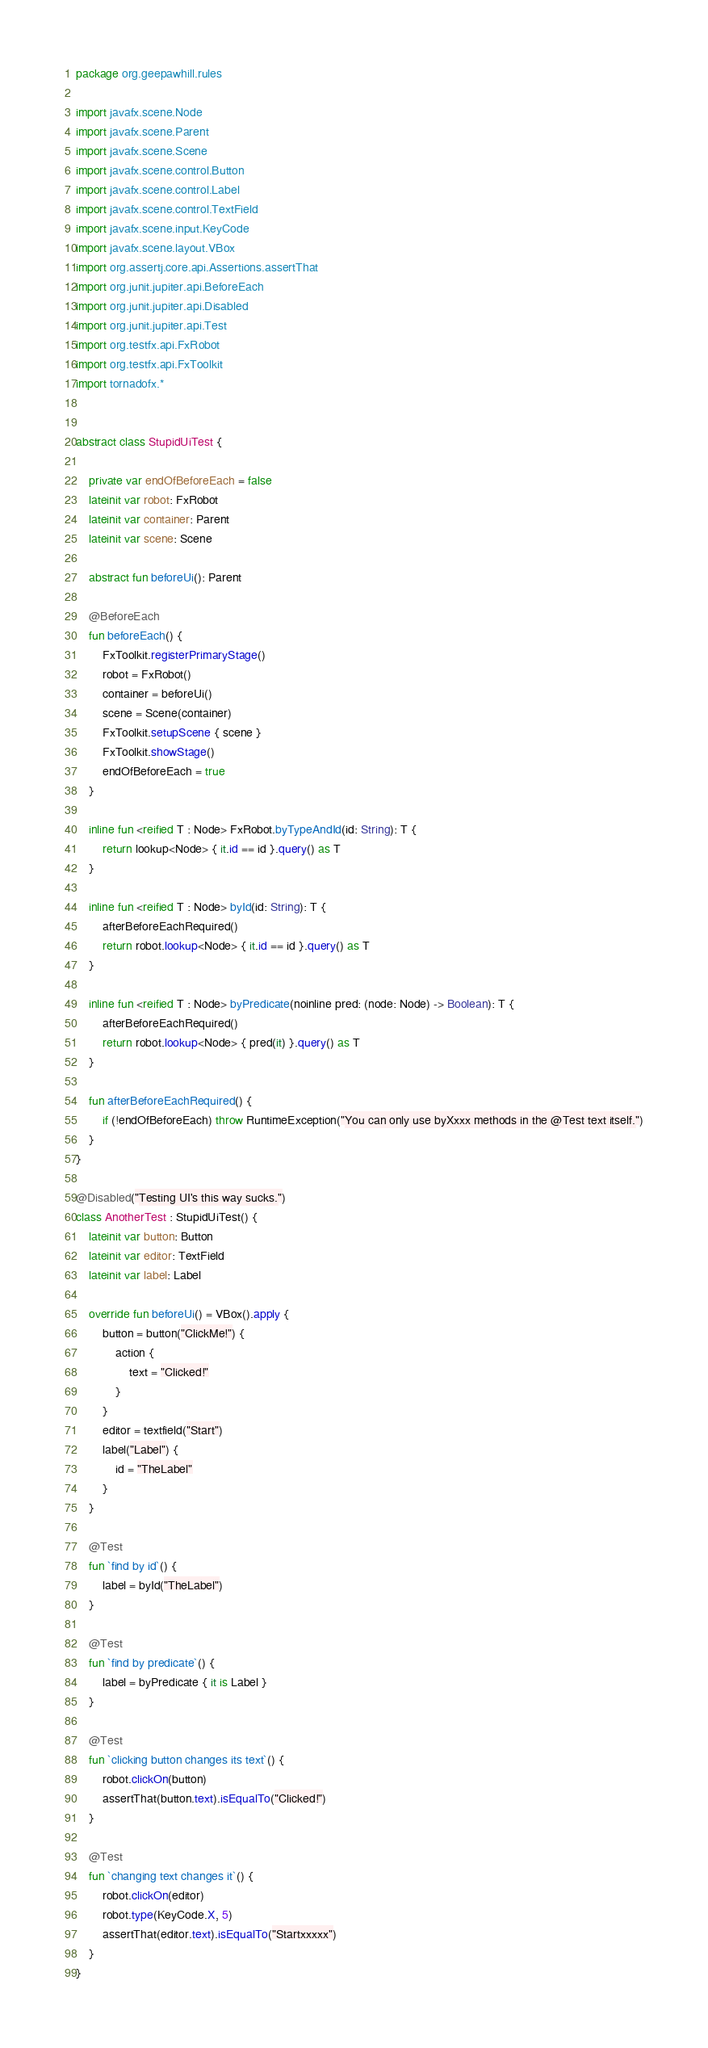Convert code to text. <code><loc_0><loc_0><loc_500><loc_500><_Kotlin_>package org.geepawhill.rules

import javafx.scene.Node
import javafx.scene.Parent
import javafx.scene.Scene
import javafx.scene.control.Button
import javafx.scene.control.Label
import javafx.scene.control.TextField
import javafx.scene.input.KeyCode
import javafx.scene.layout.VBox
import org.assertj.core.api.Assertions.assertThat
import org.junit.jupiter.api.BeforeEach
import org.junit.jupiter.api.Disabled
import org.junit.jupiter.api.Test
import org.testfx.api.FxRobot
import org.testfx.api.FxToolkit
import tornadofx.*


abstract class StupidUiTest {

    private var endOfBeforeEach = false
    lateinit var robot: FxRobot
    lateinit var container: Parent
    lateinit var scene: Scene

    abstract fun beforeUi(): Parent

    @BeforeEach
    fun beforeEach() {
        FxToolkit.registerPrimaryStage()
        robot = FxRobot()
        container = beforeUi()
        scene = Scene(container)
        FxToolkit.setupScene { scene }
        FxToolkit.showStage()
        endOfBeforeEach = true
    }

    inline fun <reified T : Node> FxRobot.byTypeAndId(id: String): T {
        return lookup<Node> { it.id == id }.query() as T
    }

    inline fun <reified T : Node> byId(id: String): T {
        afterBeforeEachRequired()
        return robot.lookup<Node> { it.id == id }.query() as T
    }

    inline fun <reified T : Node> byPredicate(noinline pred: (node: Node) -> Boolean): T {
        afterBeforeEachRequired()
        return robot.lookup<Node> { pred(it) }.query() as T
    }

    fun afterBeforeEachRequired() {
        if (!endOfBeforeEach) throw RuntimeException("You can only use byXxxx methods in the @Test text itself.")
    }
}

@Disabled("Testing UI's this way sucks.")
class AnotherTest : StupidUiTest() {
    lateinit var button: Button
    lateinit var editor: TextField
    lateinit var label: Label

    override fun beforeUi() = VBox().apply {
        button = button("ClickMe!") {
            action {
                text = "Clicked!"
            }
        }
        editor = textfield("Start")
        label("Label") {
            id = "TheLabel"
        }
    }

    @Test
    fun `find by id`() {
        label = byId("TheLabel")
    }

    @Test
    fun `find by predicate`() {
        label = byPredicate { it is Label }
    }

    @Test
    fun `clicking button changes its text`() {
        robot.clickOn(button)
        assertThat(button.text).isEqualTo("Clicked!")
    }

    @Test
    fun `changing text changes it`() {
        robot.clickOn(editor)
        robot.type(KeyCode.X, 5)
        assertThat(editor.text).isEqualTo("Startxxxxx")
    }
}</code> 